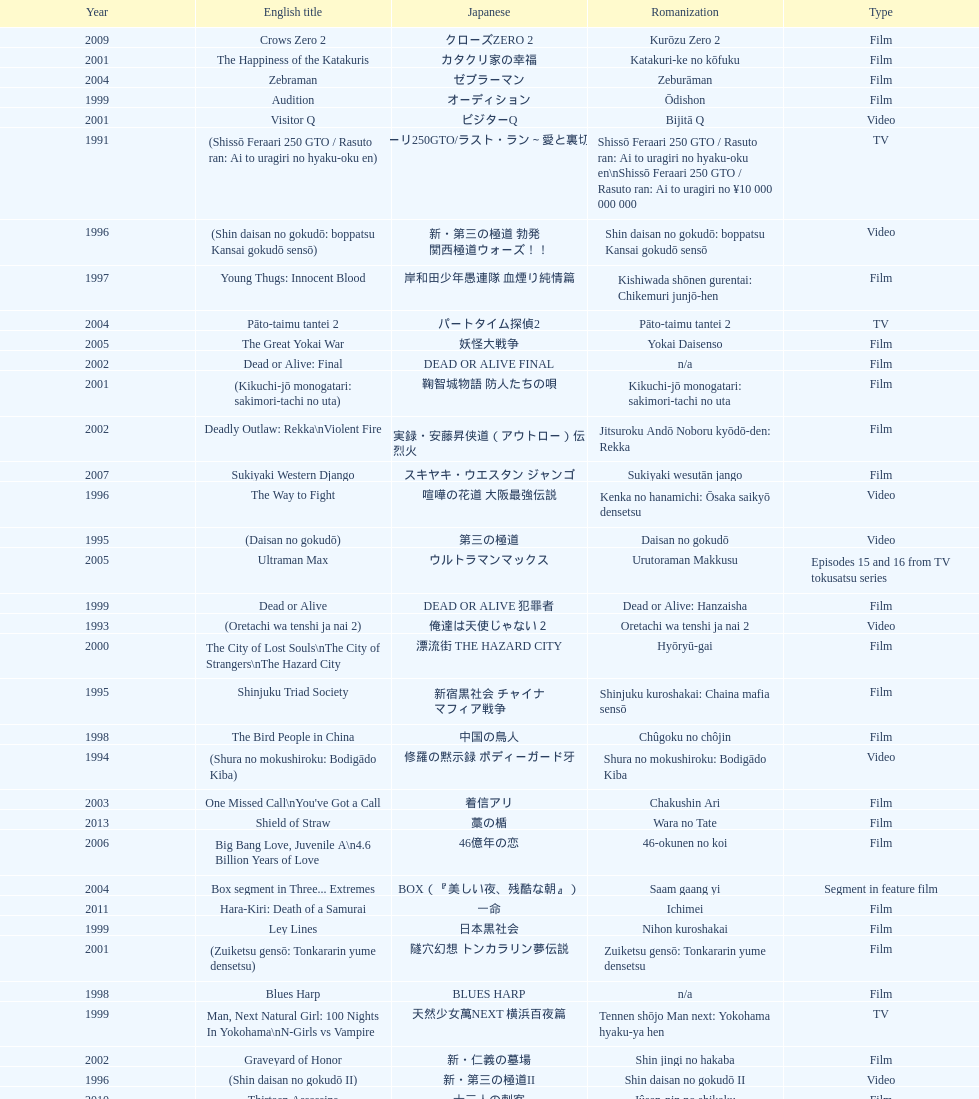Can you parse all the data within this table? {'header': ['Year', 'English title', 'Japanese', 'Romanization', 'Type'], 'rows': [['2009', 'Crows Zero 2', 'クローズZERO 2', 'Kurōzu Zero 2', 'Film'], ['2001', 'The Happiness of the Katakuris', 'カタクリ家の幸福', 'Katakuri-ke no kōfuku', 'Film'], ['2004', 'Zebraman', 'ゼブラーマン', 'Zeburāman', 'Film'], ['1999', 'Audition', 'オーディション', 'Ōdishon', 'Film'], ['2001', 'Visitor Q', 'ビジターQ', 'Bijitā Q', 'Video'], ['1991', '(Shissō Feraari 250 GTO / Rasuto ran: Ai to uragiri no hyaku-oku en)', '疾走フェラーリ250GTO/ラスト・ラン～愛と裏切りの百億円', 'Shissō Feraari 250 GTO / Rasuto ran: Ai to uragiri no hyaku-oku en\\nShissō Feraari 250 GTO / Rasuto ran: Ai to uragiri no ¥10 000 000 000', 'TV'], ['1996', '(Shin daisan no gokudō: boppatsu Kansai gokudō sensō)', '新・第三の極道 勃発 関西極道ウォーズ！！', 'Shin daisan no gokudō: boppatsu Kansai gokudō sensō', 'Video'], ['1997', 'Young Thugs: Innocent Blood', '岸和田少年愚連隊 血煙り純情篇', 'Kishiwada shōnen gurentai: Chikemuri junjō-hen', 'Film'], ['2004', 'Pāto-taimu tantei 2', 'パートタイム探偵2', 'Pāto-taimu tantei 2', 'TV'], ['2005', 'The Great Yokai War', '妖怪大戦争', 'Yokai Daisenso', 'Film'], ['2002', 'Dead or Alive: Final', 'DEAD OR ALIVE FINAL', 'n/a', 'Film'], ['2001', '(Kikuchi-jō monogatari: sakimori-tachi no uta)', '鞠智城物語 防人たちの唄', 'Kikuchi-jō monogatari: sakimori-tachi no uta', 'Film'], ['2002', 'Deadly Outlaw: Rekka\\nViolent Fire', '実録・安藤昇侠道（アウトロー）伝 烈火', 'Jitsuroku Andō Noboru kyōdō-den: Rekka', 'Film'], ['2007', 'Sukiyaki Western Django', 'スキヤキ・ウエスタン ジャンゴ', 'Sukiyaki wesutān jango', 'Film'], ['1996', 'The Way to Fight', '喧嘩の花道 大阪最強伝説', 'Kenka no hanamichi: Ōsaka saikyō densetsu', 'Video'], ['1995', '(Daisan no gokudō)', '第三の極道', 'Daisan no gokudō', 'Video'], ['2005', 'Ultraman Max', 'ウルトラマンマックス', 'Urutoraman Makkusu', 'Episodes 15 and 16 from TV tokusatsu series'], ['1999', 'Dead or Alive', 'DEAD OR ALIVE 犯罪者', 'Dead or Alive: Hanzaisha', 'Film'], ['1993', '(Oretachi wa tenshi ja nai 2)', '俺達は天使じゃない２', 'Oretachi wa tenshi ja nai 2', 'Video'], ['2000', 'The City of Lost Souls\\nThe City of Strangers\\nThe Hazard City', '漂流街 THE HAZARD CITY', 'Hyōryū-gai', 'Film'], ['1995', 'Shinjuku Triad Society', '新宿黒社会 チャイナ マフィア戦争', 'Shinjuku kuroshakai: Chaina mafia sensō', 'Film'], ['1998', 'The Bird People in China', '中国の鳥人', 'Chûgoku no chôjin', 'Film'], ['1994', '(Shura no mokushiroku: Bodigādo Kiba)', '修羅の黙示録 ボディーガード牙', 'Shura no mokushiroku: Bodigādo Kiba', 'Video'], ['2003', "One Missed Call\\nYou've Got a Call", '着信アリ', 'Chakushin Ari', 'Film'], ['2013', 'Shield of Straw', '藁の楯', 'Wara no Tate', 'Film'], ['2006', 'Big Bang Love, Juvenile A\\n4.6 Billion Years of Love', '46億年の恋', '46-okunen no koi', 'Film'], ['2004', 'Box segment in Three... Extremes', 'BOX（『美しい夜、残酷な朝』）', 'Saam gaang yi', 'Segment in feature film'], ['2011', 'Hara-Kiri: Death of a Samurai', '一命', 'Ichimei', 'Film'], ['1999', 'Ley Lines', '日本黒社会', 'Nihon kuroshakai', 'Film'], ['2001', '(Zuiketsu gensō: Tonkararin yume densetsu)', '隧穴幻想 トンカラリン夢伝説', 'Zuiketsu gensō: Tonkararin yume densetsu', 'Film'], ['1998', 'Blues Harp', 'BLUES HARP', 'n/a', 'Film'], ['1999', 'Man, Next Natural Girl: 100 Nights In Yokohama\\nN-Girls vs Vampire', '天然少女萬NEXT 横浜百夜篇', 'Tennen shōjo Man next: Yokohama hyaku-ya hen', 'TV'], ['2002', 'Graveyard of Honor', '新・仁義の墓場', 'Shin jingi no hakaba', 'Film'], ['1996', '(Shin daisan no gokudō II)', '新・第三の極道II', 'Shin daisan no gokudō II', 'Video'], ['2010', 'Thirteen Assassins', '十三人の刺客', 'Jûsan-nin no shikaku', 'Film'], ['2002', 'Sabu', 'SABU さぶ', 'Sabu', 'TV'], ['1998', 'Andromedia', 'アンドロメデイア andromedia', 'Andoromedia', 'Film'], ['2008', "God's Puzzle", '神様のパズル', 'Kamisama no pazuru', 'Film'], ['2001', 'Family', 'FAMILY', 'n/a', 'Film'], ['2009', 'Yatterman', 'ヤッターマン', 'Yattaaman', 'Film'], ['1996', '(Piinattsu: Rakkasei)', 'ピイナッツ 落華星', 'Piinattsu: Rakkasei', 'Video'], ['2007', 'Crows Zero', 'クローズZERO', 'Kurōzu Zero', 'Film'], ['2002', 'Pāto-taimu tantei', 'パートタイム探偵', 'Pāto-taimu tantei', 'TV series'], ['2013', 'The Mole Song: Undercover Agent Reiji', '土竜の唄\u3000潜入捜査官 REIJI', 'Mogura no uta – sennyu sosakan: Reiji', 'Film'], ['1999', 'Man, A Natural Girl', '天然少女萬', 'Tennen shōjo Man', 'TV'], ['2006', 'Waru: kanketsu-hen', '', 'Waru: kanketsu-hen', 'Video'], ['2010', 'Zebraman 2: Attack on Zebra City', 'ゼブラーマン -ゼブラシティの逆襲', 'Zeburāman -Zebura Shiti no Gyakushū', 'Film'], ['1995', 'Osaka Tough Guys', 'なにわ遊侠伝', 'Naniwa yūkyōden', 'Video'], ['2003', 'Gozu', '極道恐怖大劇場 牛頭 GOZU', 'Gokudō kyōfu dai-gekijō: Gozu', 'Film'], ['2007', 'Like a Dragon', '龍が如く 劇場版', 'Ryu ga Gotoku Gekijōban', 'Film'], ['2003', 'Kōshōnin', '交渉人', 'Kōshōnin', 'TV'], ['1992', 'A Human Murder Weapon', '人間兇器 愛と怒りのリング', 'Ningen kyōki: Ai to ikari no ringu', 'Video'], ['1998', 'Young Thugs: Nostalgia', '岸和田少年愚連隊 望郷', 'Kishiwada shōnen gurentai: Bōkyō', 'Film'], ['2001', 'Agitator', '荒ぶる魂たち', 'Araburu tamashii-tachi', 'Film'], ['1996', 'Fudoh: The New Generation', '極道戦国志 不動', 'Gokudō sengokushi: Fudō', 'Film'], ['2002', 'Shangri-La', '金融破滅ニッポン 桃源郷の人々', "Kin'yū hametsu Nippon: Tōgenkyō no hito-bito", 'Film'], ['1995', '(Shura no mokushiroku 2: Bodigādo Kiba)', '修羅の黙示録2 ボディーガード牙', 'Shura no mokushiroku 2: Bodigādo Kiba', 'Video'], ['2000', 'Dead or Alive 2: Birds\\nDead or Alive 2: Runaway', 'DEAD OR ALIVE 2 逃亡者', 'Dead or Alive 2: Tōbōsha', 'Film'], ['1991', '(Toppū! Minipato tai - Aikyacchi Jankushon)', '突風！ ミニパト隊 アイキャッチ・ジャンクション', 'Toppū! Minipato tai - Aikyatchi Jankushon', 'Video'], ['1997', 'Rainy Dog', '極道黒社会 RAINY DOG', 'Gokudō kuroshakai', 'Film'], ['1993', 'Bodyguard Kiba', 'ボディガード牙', 'Bodigādo Kiba', 'Video'], ['2002', 'Pandōra', 'パンドーラ', 'Pandōra', 'Music video'], ['2002', '(Onna kunishū ikki)', 'おんな 国衆一揆', 'Onna kunishū ikki', '(unknown)'], ['2007', 'Zatoichi', '座頭市', 'Zatōichi', 'Stageplay'], ['2006', 'Waru', 'WARU', 'Waru', 'Film'], ['1997', '(Jingi naki yabō 2)', '仁義なき野望2', 'Jingi naki yabō 2', 'Video'], ['2000', "The Making of 'Gemini'", '(unknown)', "Tsukamoto Shin'ya ga Ranpo suru", 'TV documentary'], ['1996', '(Jingi naki yabō)', '仁義なき野望', 'Jingi naki yabō', 'Video'], ['1993', '(Oretachi wa tenshi ja nai)', '俺達は天使じゃない', 'Oretachi wa tenshi ja nai', 'Video'], ['2000', 'MPD Psycho', '多重人格探偵サイコ', 'Tajū jinkaku tantei saiko: Amamiya Kazuhiko no kikan', 'TV miniseries'], ['2012', "For Love's Sake", '愛と誠', 'Ai to makoto', 'Film'], ['1997', 'Full Metal Yakuza', 'FULL METAL 極道', 'Full Metal gokudō', 'Video'], ['1991', '(Redi hantā: Koroshi no pureryuudo)', 'レディハンター 殺しのプレュード', 'Redi hantā: Koroshi no pureryūdo', 'Video'], ['2012', 'Ace Attorney', '逆転裁判', 'Gyakuten Saiban', 'Film'], ['2004', 'Izo', 'IZO', 'IZO', 'Film'], ['2008', 'K-tai Investigator 7', 'ケータイ捜査官7', 'Keitai Sōsakan 7', 'TV'], ['2006', 'Sun Scarred', '太陽の傷', 'Taiyo no kizu', 'Film'], ['1999', 'Salaryman Kintaro\\nWhite Collar Worker Kintaro', 'サラリーマン金太郎', 'Sarariiman Kintarō', 'Film'], ['2012', 'Lesson of the Evil', '悪の教典', 'Aku no Kyōten', 'Film'], ['2001', 'Ichi the Killer', '殺し屋1', 'Koroshiya 1', 'Film'], ['2006', 'Imprint episode from Masters of Horror', 'インプリント ～ぼっけえ、きょうてえ～', 'Inpurinto ~bokke kyote~', 'TV episode'], ['2003', 'Yakuza Demon', '鬼哭 kikoku', 'Kikoku', 'Video'], ['2007', 'Detective Story', '探偵物語', 'Tantei monogatari', 'Film'], ['2003', 'The Man in White', '許されざる者', 'Yurusarezaru mono', 'Film'], ['1999', 'Silver', 'シルバー SILVER', 'Silver: shirubā', 'Video'], ['2011', 'Ninja Kids!!!', '忍たま乱太郎', 'Nintama Rantarō', 'Film'], ['1994', 'Shinjuku Outlaw', '新宿アウトロー', 'Shinjuku autorou', 'Video'], ['2000', 'The Guys from Paradise', '天国から来た男たち', 'Tengoku kara kita otoko-tachi', 'Film']]} How many years is the chart for? 23. 